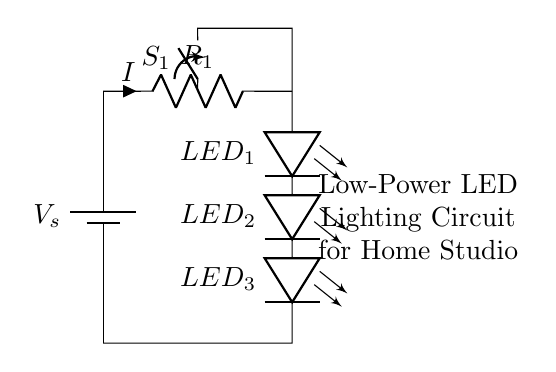What is the voltage source of this circuit? The voltage source is labeled as V_s and has a value of 12V, clearly indicated in the circuit.
Answer: 12V What type of components are used for lighting in this circuit? The circuit utilizes LEDs as the lighting components, shown as leDo in the diagram.
Answer: LEDs How many LEDs are there in the circuit? The circuit diagram shows three LEDs arranged in series, labeled as LED_1, LED_2, and LED_3.
Answer: 3 What is the purpose of the resistor in the circuit? The resistor, labeled R_1, serves as a current limiting component to prevent excessive current from flowing through the LEDs.
Answer: Current limiting What is the function of the switch in this circuit? The switch, labeled S_1, allows the user to open or close the circuit, thereby turning the LED lights on or off.
Answer: On/Off control What is the relationship between the resistor and the current? The current, indicated as I, flows through the resistor R_1, and its value is determined based on the resistor’s resistance and the applied voltage, in accordance with Ohm’s law.
Answer: Current flow Is this circuit designed for low power usage? Yes, the circuit is specifically designed for low power applications, as indicated by the use of low-power LEDs and a modest voltage supply.
Answer: Yes 